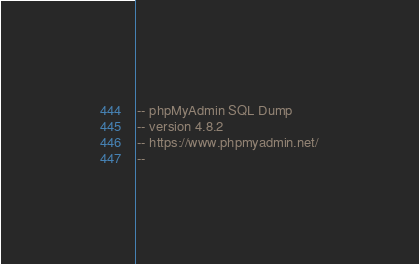<code> <loc_0><loc_0><loc_500><loc_500><_SQL_>-- phpMyAdmin SQL Dump
-- version 4.8.2
-- https://www.phpmyadmin.net/
--</code> 